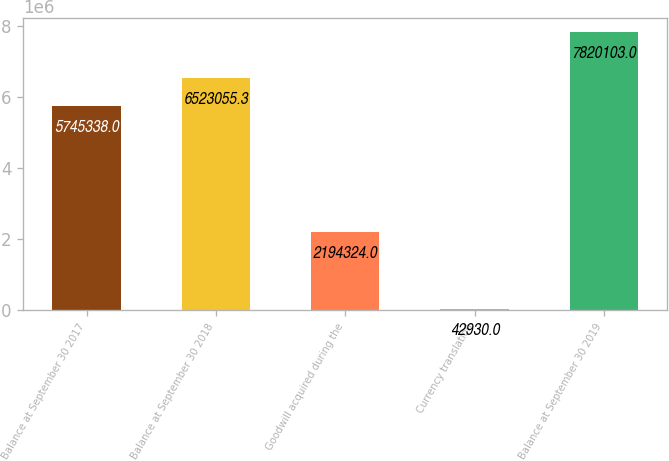Convert chart. <chart><loc_0><loc_0><loc_500><loc_500><bar_chart><fcel>Balance at September 30 2017<fcel>Balance at September 30 2018<fcel>Goodwill acquired during the<fcel>Currency translation<fcel>Balance at September 30 2019<nl><fcel>5.74534e+06<fcel>6.52306e+06<fcel>2.19432e+06<fcel>42930<fcel>7.8201e+06<nl></chart> 